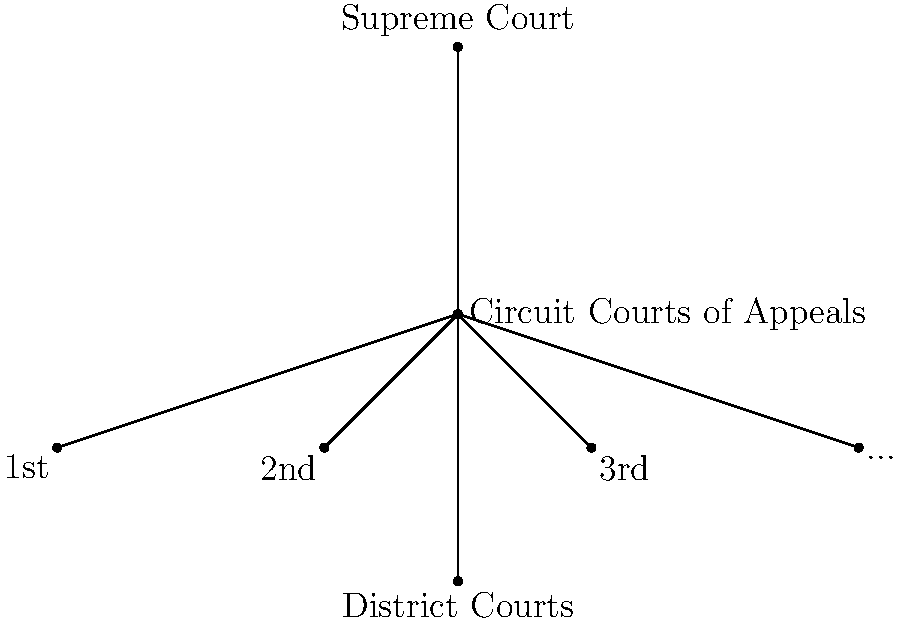As a high-ranking government official consulting with the judge on constitutional matters, you are presented with the above organizational chart of the federal court system. Which level of courts serves as the primary trial courts in the federal system, and how does their position in the hierarchy affect the appeals process? To answer this question, let's analyze the organizational chart step-by-step:

1. The chart shows three main levels of federal courts:
   - At the top: Supreme Court
   - In the middle: Circuit Courts of Appeals
   - At the bottom: District Courts

2. District Courts are at the lowest level of the federal court system. This positioning indicates that they are the courts of first instance or primary trial courts in the federal system.

3. The hierarchical structure shows that cases typically begin in the District Courts and can be appealed upwards.

4. Appeals from District Courts go to the Circuit Courts of Appeals, as indicated by the lines connecting these two levels.

5. The Supreme Court sits at the apex of the system, hearing cases on appeal from the Circuit Courts of Appeals or, in rare cases, directly from District Courts.

6. This structure ensures that most cases are first heard in District Courts, allowing for a thorough examination of facts and application of law at the trial level.

7. The appeals process then allows for review of legal issues by higher courts, with the Circuit Courts of Appeals serving as intermediate appellate courts.

8. The position of District Courts at the base of the hierarchy means that their decisions can be reviewed by two levels of higher courts, ensuring multiple opportunities for error correction and legal interpretation.
Answer: District Courts; their position allows for appeals to Circuit Courts and potentially to the Supreme Court. 